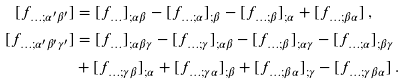Convert formula to latex. <formula><loc_0><loc_0><loc_500><loc_500>[ f _ { \dots ; \alpha ^ { \prime } \beta ^ { \prime } } ] & = [ f _ { \dots } ] _ { ; \alpha \beta } - [ f _ { \dots ; \alpha } ] _ { ; \beta } - [ f _ { \dots ; \beta } ] _ { ; \alpha } + [ f _ { \dots ; \beta \alpha } ] \, , \\ [ f _ { \dots ; \alpha ^ { \prime } \beta ^ { \prime } \gamma ^ { \prime } } ] & = [ f _ { \dots } ] _ { ; \alpha \beta \gamma } - [ f _ { \dots ; \gamma } ] _ { ; \alpha \beta } - [ f _ { \dots ; \beta } ] _ { ; \alpha \gamma } - [ f _ { \dots ; \alpha } ] _ { ; \beta \gamma } \\ & + [ f _ { \dots ; \gamma \beta } ] _ { ; \alpha } + [ f _ { \dots ; \gamma \alpha } ] _ { ; \beta } + [ f _ { \dots ; \beta \alpha } ] _ { ; \gamma } - [ f _ { \dots ; \gamma \beta \alpha } ] \, .</formula> 